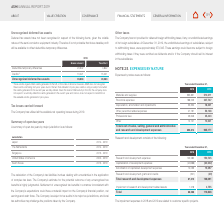According to Asm International Nv's financial document, Why are Deferred tax assets not recognized for the items in the table? Based on the financial document, the answer is given the volatile nature of the semi-conductor equipment industry. Also, What is the gross amount of  Deductible temporary differences ? According to the financial document, 20,642. The relevant text states: "Deductible temporary differences 20,642 4,842..." Also, What is the  Tax effect of credits? According to the financial document, 15,221. The relevant text states: "Credits 1) 15,221 15,221..." Also, can you calculate: What is the gross Deductible temporary differences expressed as a percentage of gross Unrecognized deferred tax assets? Based on the calculation:  20,642 / 35,863 , the result is 57.56 (percentage). This is based on the information: "Deductible temporary differences 20,642 4,842 Unrecognized deferred tax assets 35,863 20,063..." The key data points involved are: 20,642, 35,863. Also, can you calculate: What is the tax effect of Deductible temporary differences expressed as a ratio of gross Deductible temporary differences? Based on the calculation: 4,842/20,642, the result is 0.23. This is based on the information: "Deductible temporary differences 20,642 4,842 Deductible temporary differences 20,642 4,842..." The key data points involved are: 20,642, 4,842. Also, can you calculate: What is the difference in the gross amount of  Deductible temporary differences and Credits? Based on the calculation: 20,642-15,221, the result is 5421. This is based on the information: "Deductible temporary differences 20,642 4,842 Credits 1) 15,221 15,221..." The key data points involved are: 15,221, 20,642. 